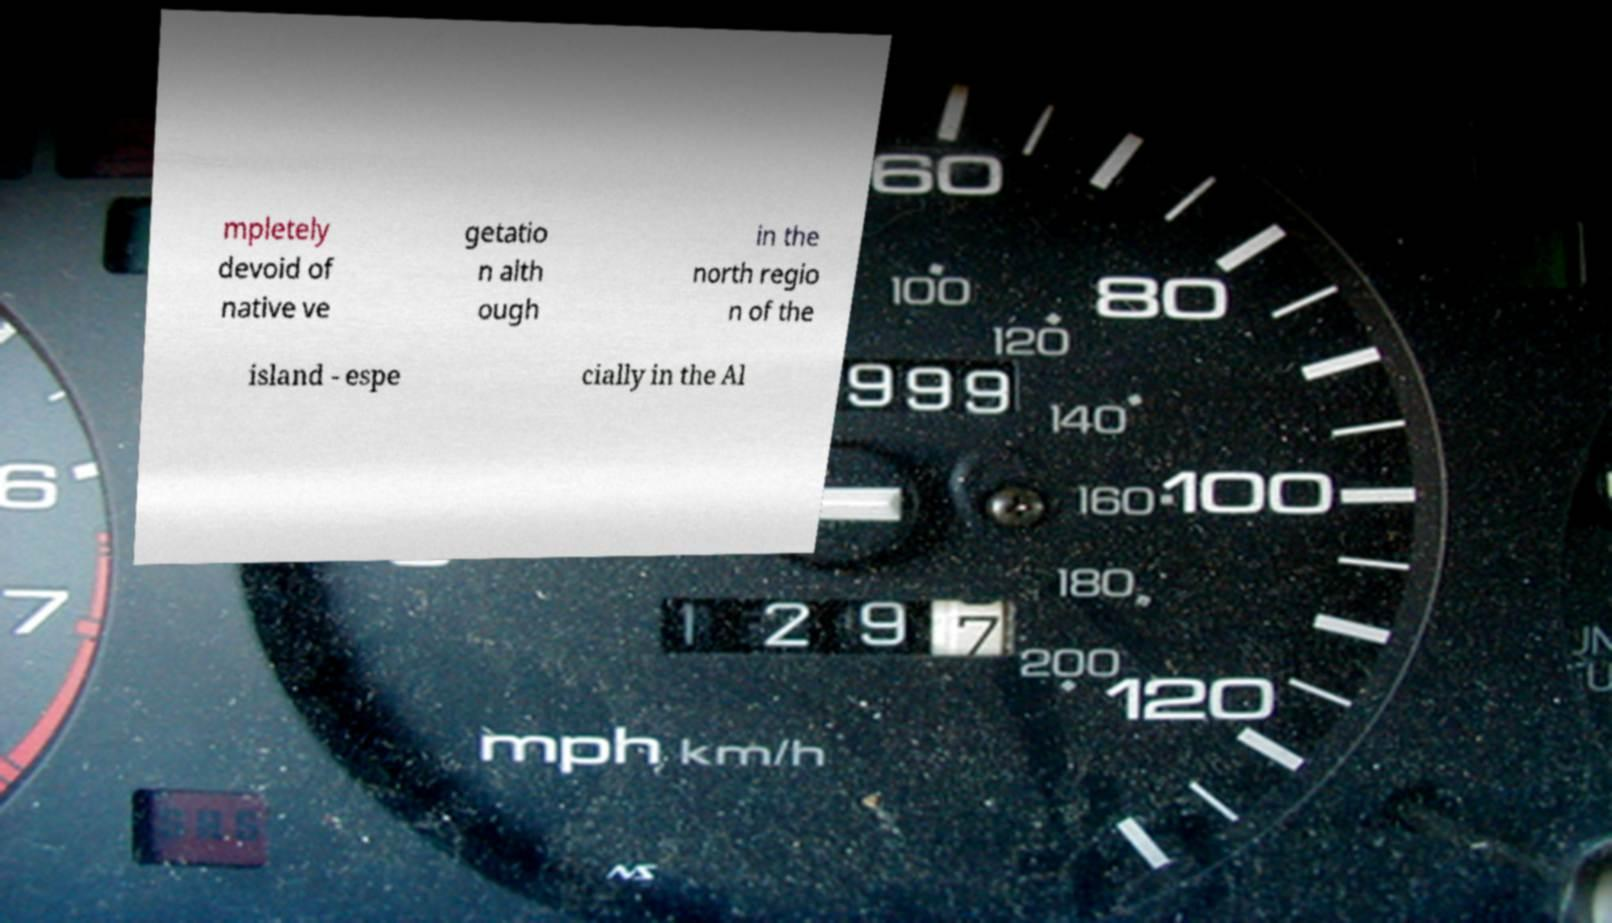Could you extract and type out the text from this image? mpletely devoid of native ve getatio n alth ough in the north regio n of the island - espe cially in the Al 